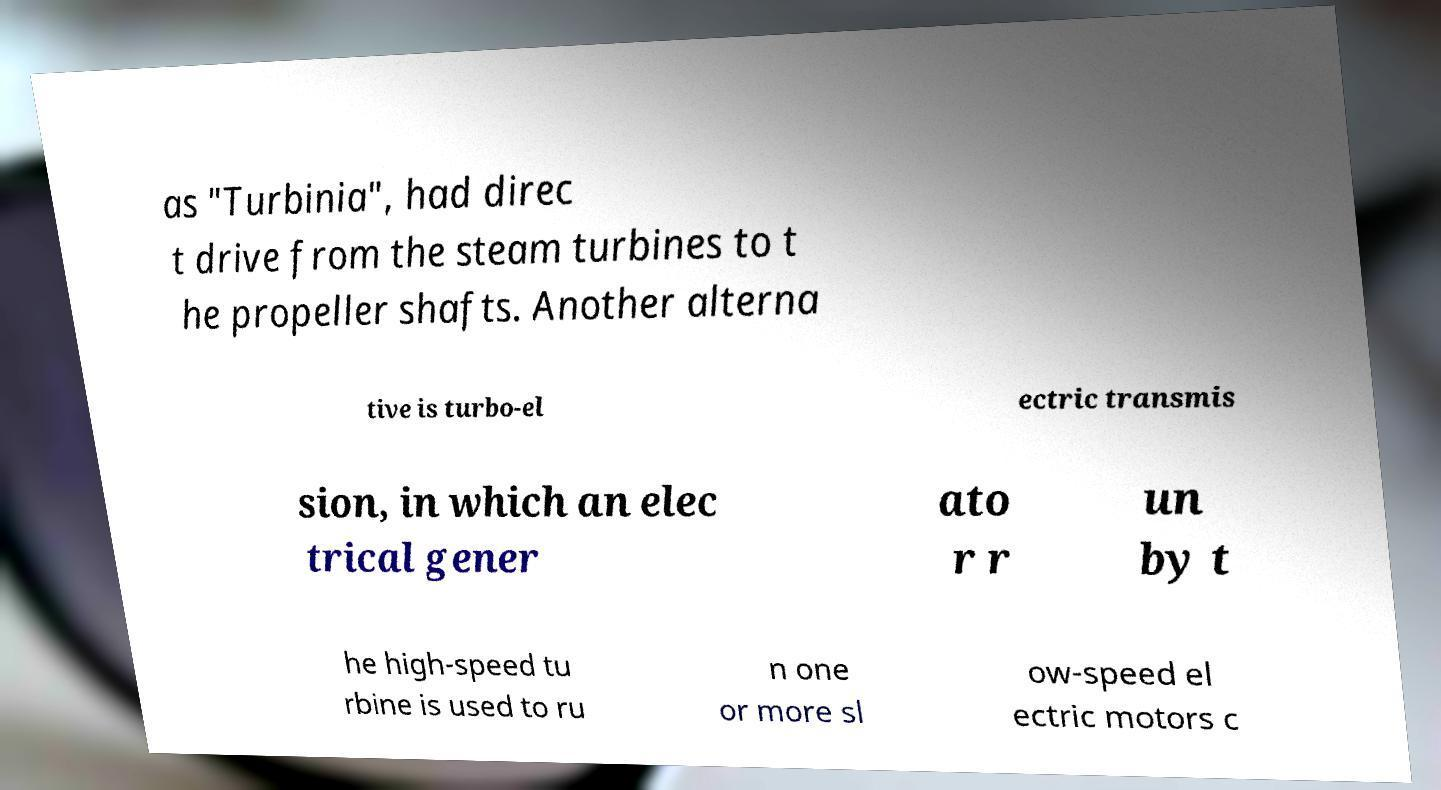Please identify and transcribe the text found in this image. as "Turbinia", had direc t drive from the steam turbines to t he propeller shafts. Another alterna tive is turbo-el ectric transmis sion, in which an elec trical gener ato r r un by t he high-speed tu rbine is used to ru n one or more sl ow-speed el ectric motors c 